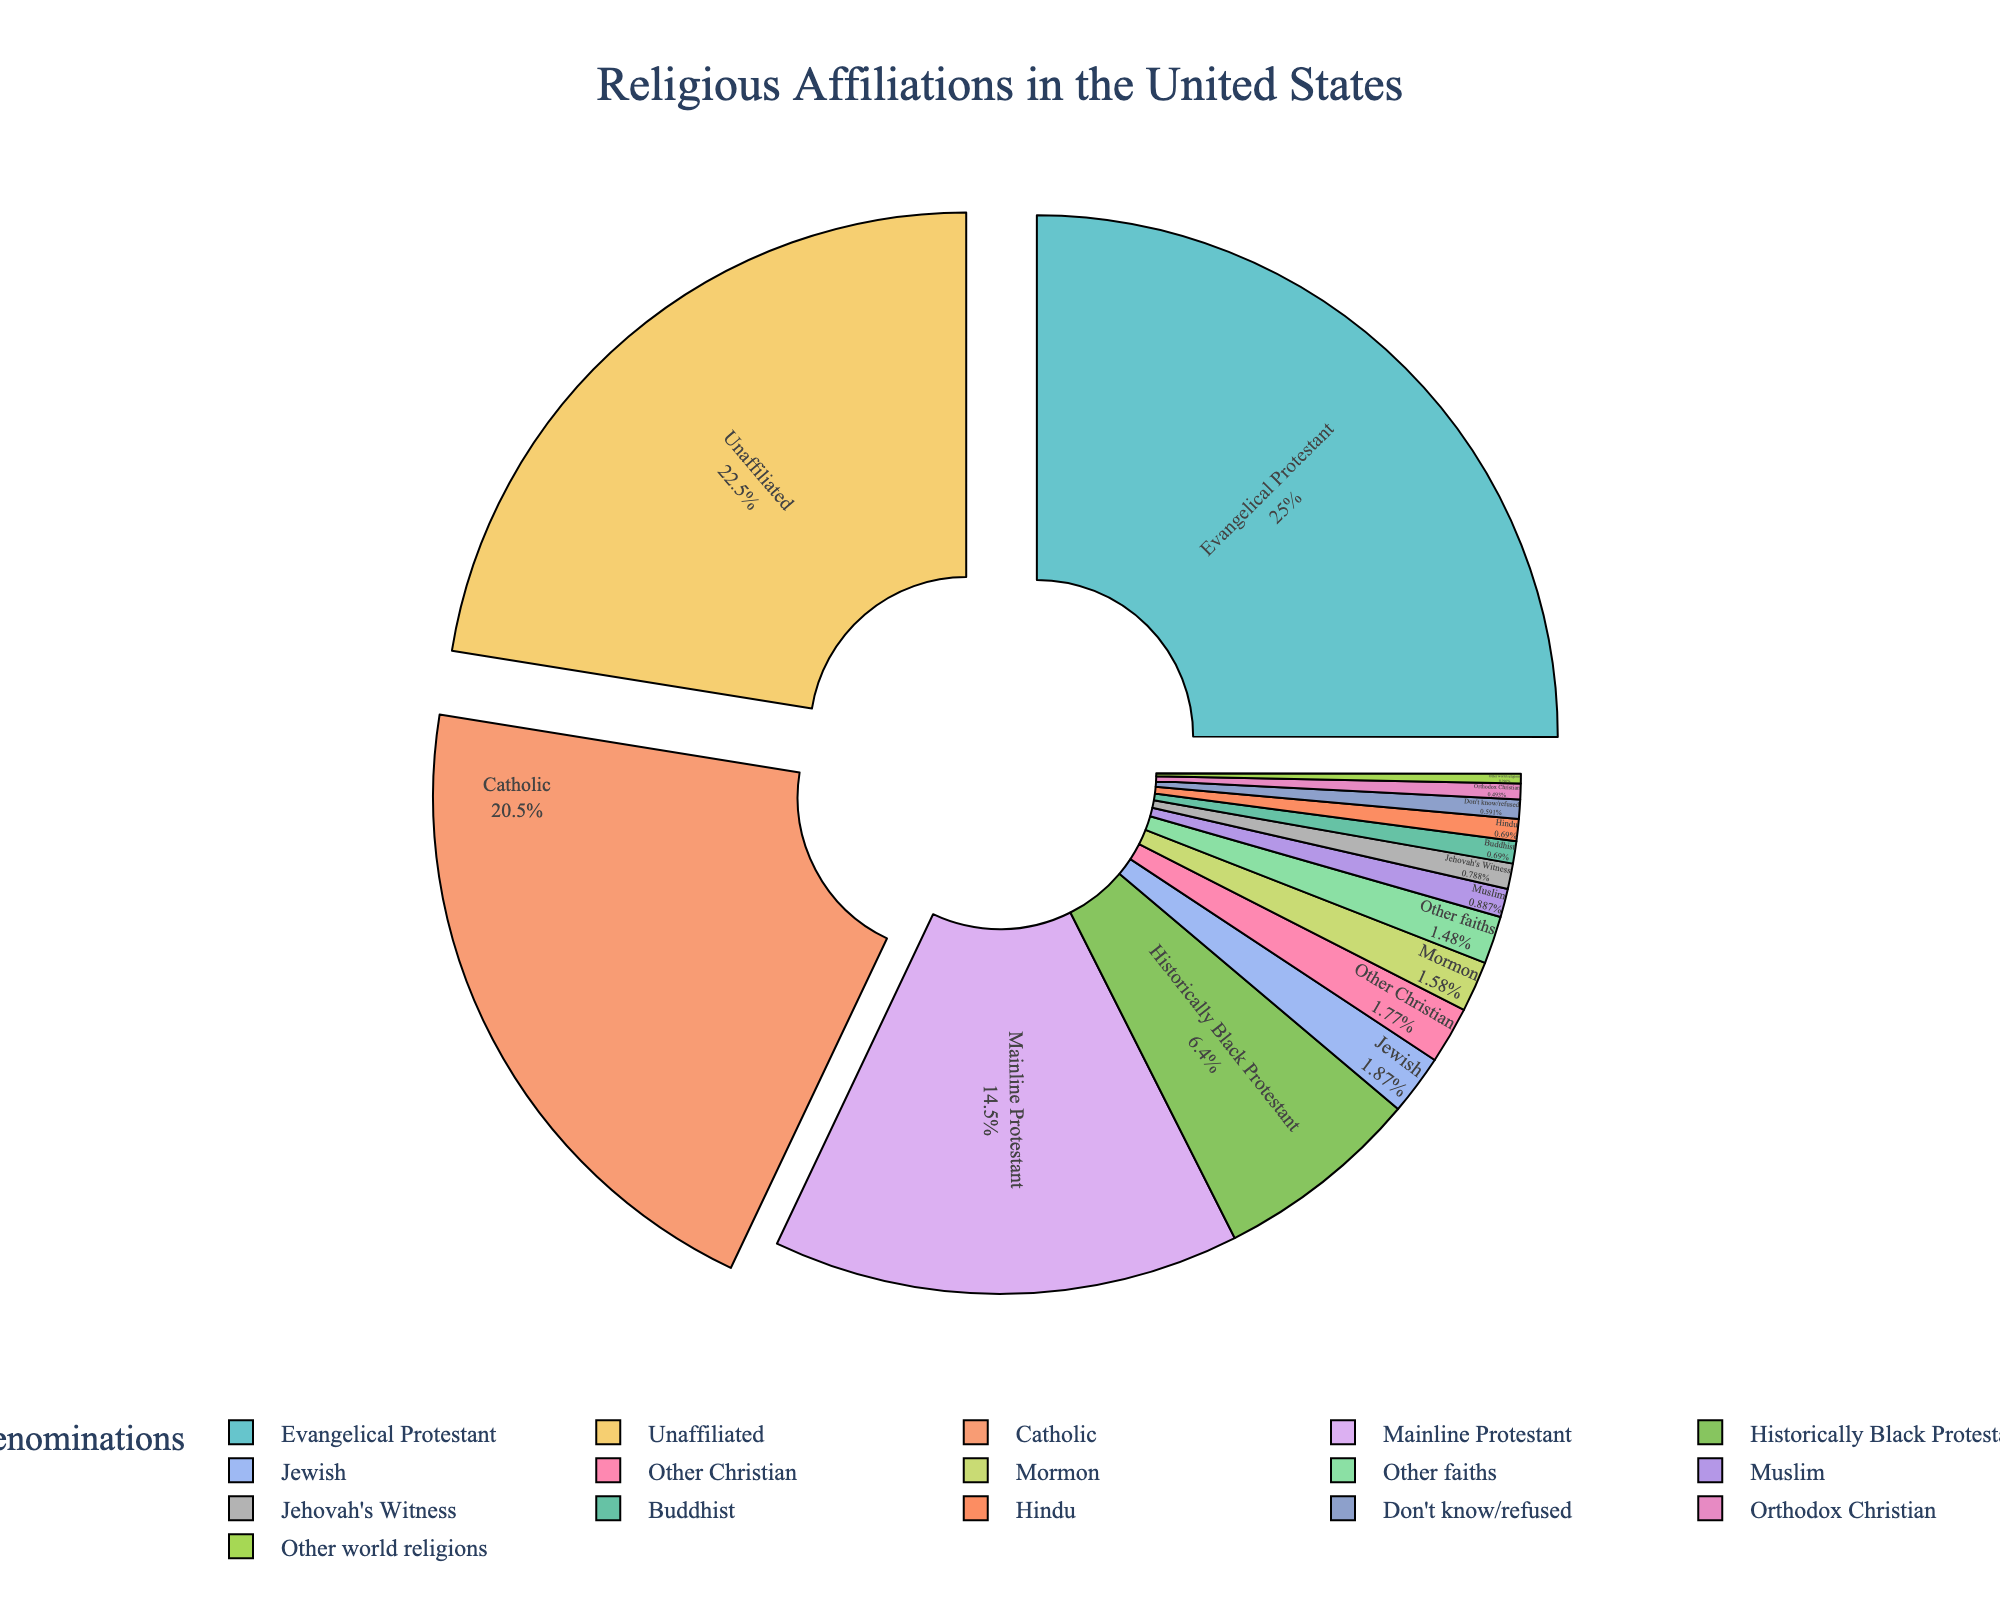what religious group has the second highest percentage? The pie chart shows all religious affiliations in descending order based on their percentage. The second largest segment after Evangelical Protestant (25.4%) is Catholic with 20.8%.
Answer: Catholic What is the combined percentage of Evangelical Protestant and Catholic? Add the percentages of Evangelical Protestant (25.4%) and Catholic (20.8%) which equals 46.2%.
Answer: 46.2% Which religious groups have a percentage less than 1%? The groups labeled on the pie chart as having under 1% are Mormon (1.6%), Orthodox Christian (0.5%), Jehovah's Witness (0.8%), Jewish (1.9%), Muslim (0.9%), Buddhist (0.7%), Hindu (0.7%), Other world religions (0.3%), Other faiths (1.5%), and Don't know/refused (0.6%). Thus, only Mormon (1.6%) and Jewish (1.9%) exceed 1%, and the remaining groups meet the criteria.
Answer: Orthodox Christian, Jehovah's Witness, Muslim, Buddhist, Hindu, Other world religions, Other faiths, Don't know/refused How does the percentage of unaffiliated compare to mainline Protestant? According to the chart, Unaffiliated has a percentage of 22.8% and Mainline Protestant has 14.7%. Unaffiliated is greater than Mainline Protestant.
Answer: Unaffiliated is greater What is the visual relationship between the top three denominations in the pie chart? The top three denominations (Evangelical Protestant, Catholic, and Unaffiliated) are visually represented by the most prominent and largest segments of the pie chart. The chart shows the Evangelical Protestant segment as the largest, followed by the Catholic segment, and then the Unaffiliated segment, each with distinct colors.
Answer: Evangelical Protestant, Catholic, Unaffiliated What is the total percentage for all Protestant groups combined? Sum the percentages of Evangelical Protestant (25.4%), Mainline Protestant (14.7%), and Historically Black Protestant (6.5%) to get 46.6%.
Answer: 46.6% What is the difference between the percentage of historically black Protestant and Orthodox Christian? Subtract the Orthodox Christian percentage (0.5%) from the Historically Black Protestant percentage (6.5%) which equals 6%.
Answer: 6% Which groups fall below the “Other” category and how does their combined percentage compare to that of Mormon? Add the percentages of Other world religions (0.3%) and Other faiths (1.5%) which equals 1.8%. Compare this to Mormon, which has 1.6%.
Answer: Other groups combined are slightly higher 